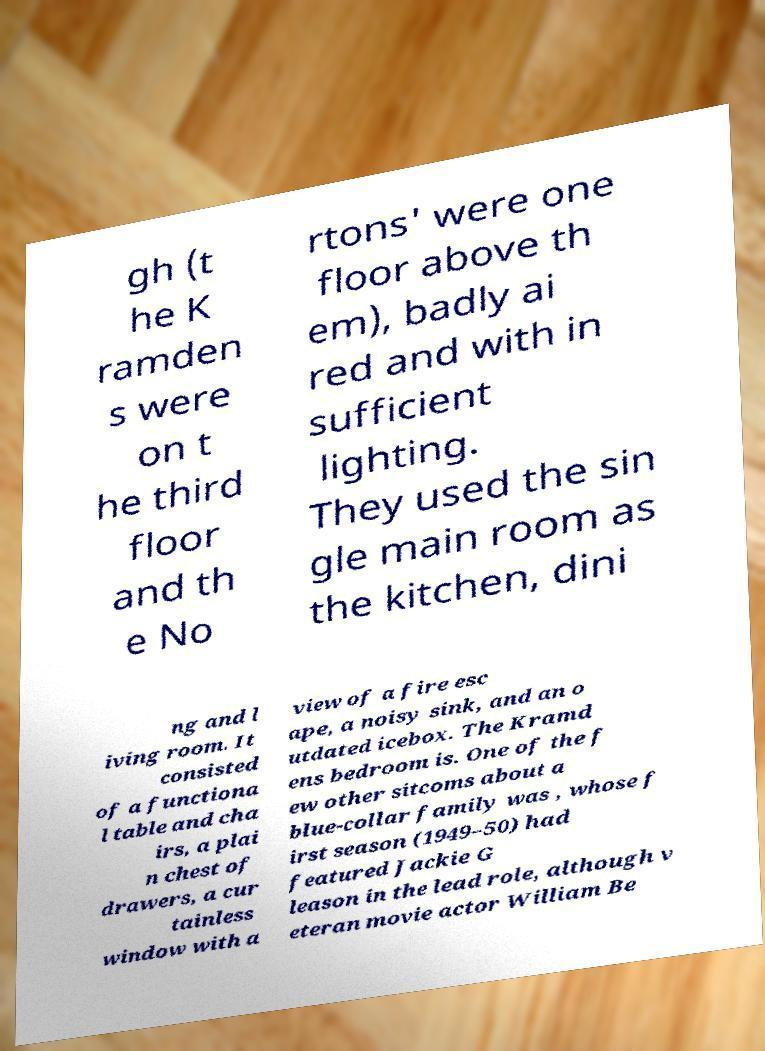Please read and relay the text visible in this image. What does it say? gh (t he K ramden s were on t he third floor and th e No rtons' were one floor above th em), badly ai red and with in sufficient lighting. They used the sin gle main room as the kitchen, dini ng and l iving room. It consisted of a functiona l table and cha irs, a plai n chest of drawers, a cur tainless window with a view of a fire esc ape, a noisy sink, and an o utdated icebox. The Kramd ens bedroom is. One of the f ew other sitcoms about a blue-collar family was , whose f irst season (1949–50) had featured Jackie G leason in the lead role, although v eteran movie actor William Be 